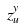Convert formula to latex. <formula><loc_0><loc_0><loc_500><loc_500>z _ { u } ^ { y }</formula> 